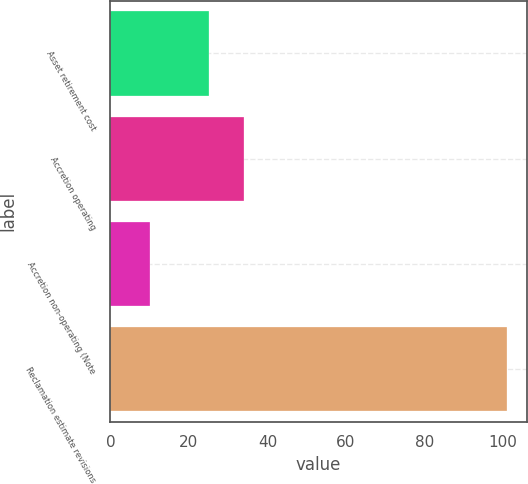Convert chart. <chart><loc_0><loc_0><loc_500><loc_500><bar_chart><fcel>Asset retirement cost<fcel>Accretion operating<fcel>Accretion non-operating (Note<fcel>Reclamation estimate revisions<nl><fcel>25<fcel>34.1<fcel>10<fcel>101<nl></chart> 